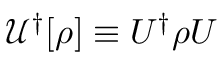Convert formula to latex. <formula><loc_0><loc_0><loc_500><loc_500>\mathcal { U } ^ { \dagger } [ \rho ] \equiv U ^ { \dagger } \rho U</formula> 